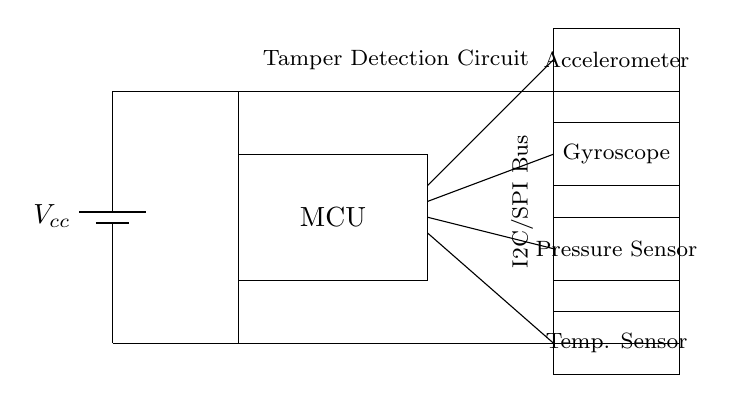What is the main component of this circuit? The main component is the microcontroller, which processes data from the sensors and manages their operations.
Answer: Microcontroller What type of sensors are included in the circuit? The circuit includes an accelerometer, gyroscope, pressure sensor, and temperature sensor, all integrated for capturing different environmental cues.
Answer: Accelerometer, gyroscope, pressure sensor, temperature sensor How many sensors are connected to the microcontroller? There are four sensors connected to the microcontroller, as seen in the connections leading from the MCU to each sensor.
Answer: Four What communication bus is used for the sensors? The communication between the microcontroller and sensors is facilitated through an I2C/SPI bus, which allows for efficient data transfers.
Answer: I2C/SPI Bus What is the purpose of the tamper detection circuit? The tamper detection circuit is designed to monitor for any unusual behavior or unauthorized access attempts to the device, thereby enhancing security.
Answer: Security How does the power supply connect in the circuit? The power supply connects to the microcontroller and extends to all sensors, ensuring they receive the necessary voltage to operate properly.
Answer: Parallel What is the output of the sensors based on unusual behavior? The sensors provide data that can be analyzed by the microcontroller for detecting anomalies or unusual patterns indicating tampering or device misuse.
Answer: Data Analysis 